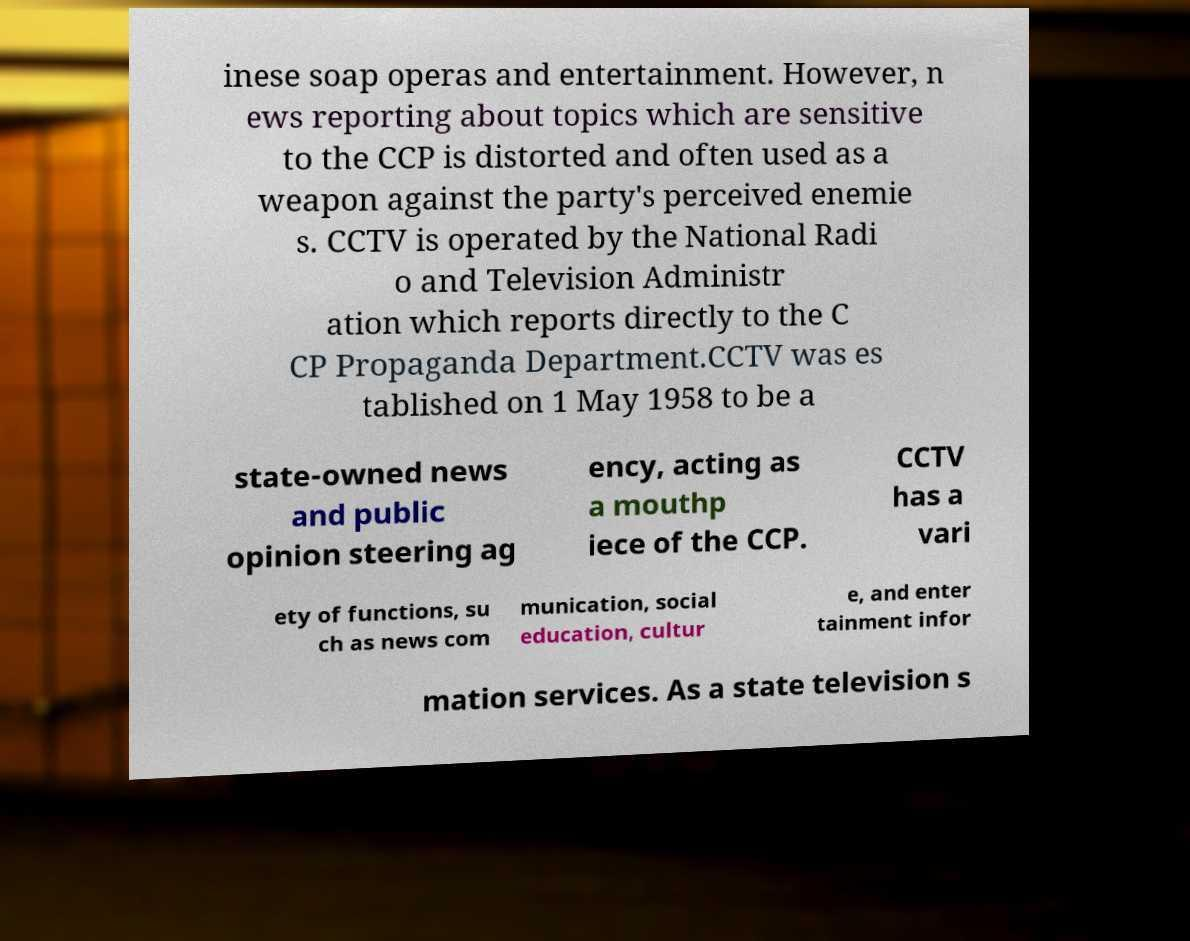Could you extract and type out the text from this image? inese soap operas and entertainment. However, n ews reporting about topics which are sensitive to the CCP is distorted and often used as a weapon against the party's perceived enemie s. CCTV is operated by the National Radi o and Television Administr ation which reports directly to the C CP Propaganda Department.CCTV was es tablished on 1 May 1958 to be a state-owned news and public opinion steering ag ency, acting as a mouthp iece of the CCP. CCTV has a vari ety of functions, su ch as news com munication, social education, cultur e, and enter tainment infor mation services. As a state television s 